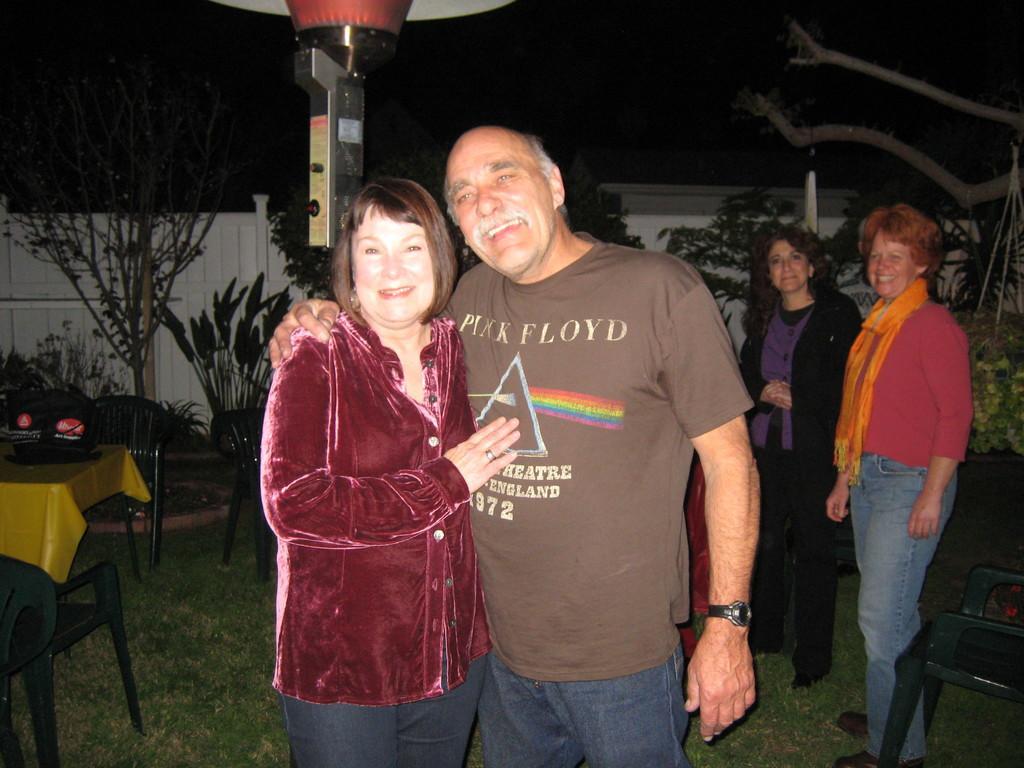Describe this image in one or two sentences. In this picture there is a woman and a man. Both are smiling. In the background there are some people standing. There is a plants, trees, a railing here. In front of the railing there is a chair and a table. 